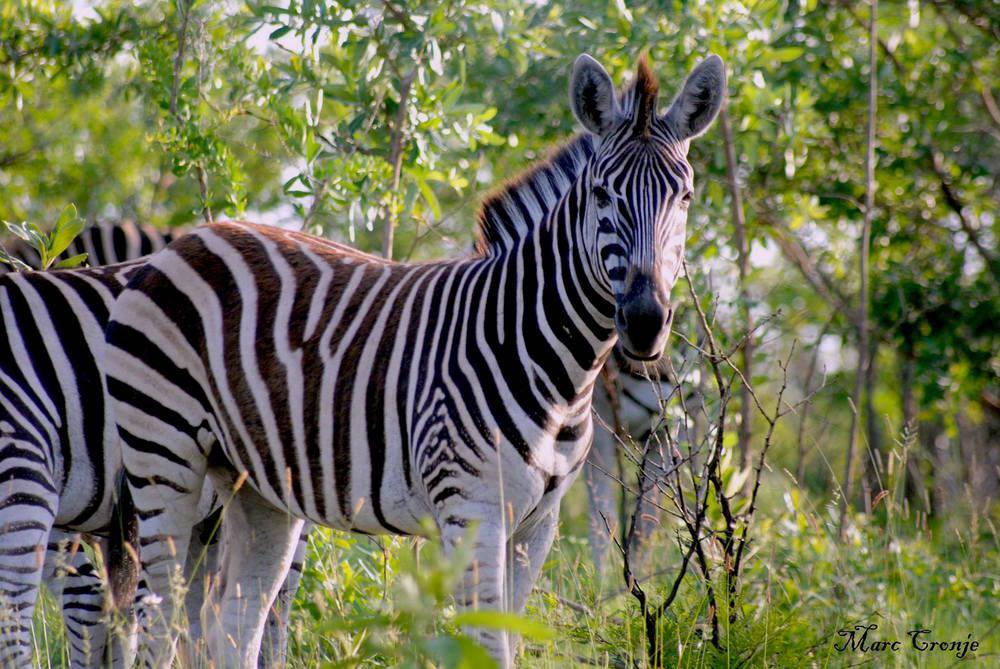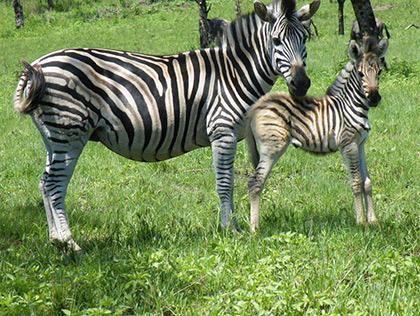The first image is the image on the left, the second image is the image on the right. Considering the images on both sides, is "A taller standing zebra is left of a smaller standing zebra in one image, and the other image shows a zebra standing with its body turned rightward." valid? Answer yes or no. Yes. The first image is the image on the left, the second image is the image on the right. For the images shown, is this caption "There is more than one species of animal present." true? Answer yes or no. No. 